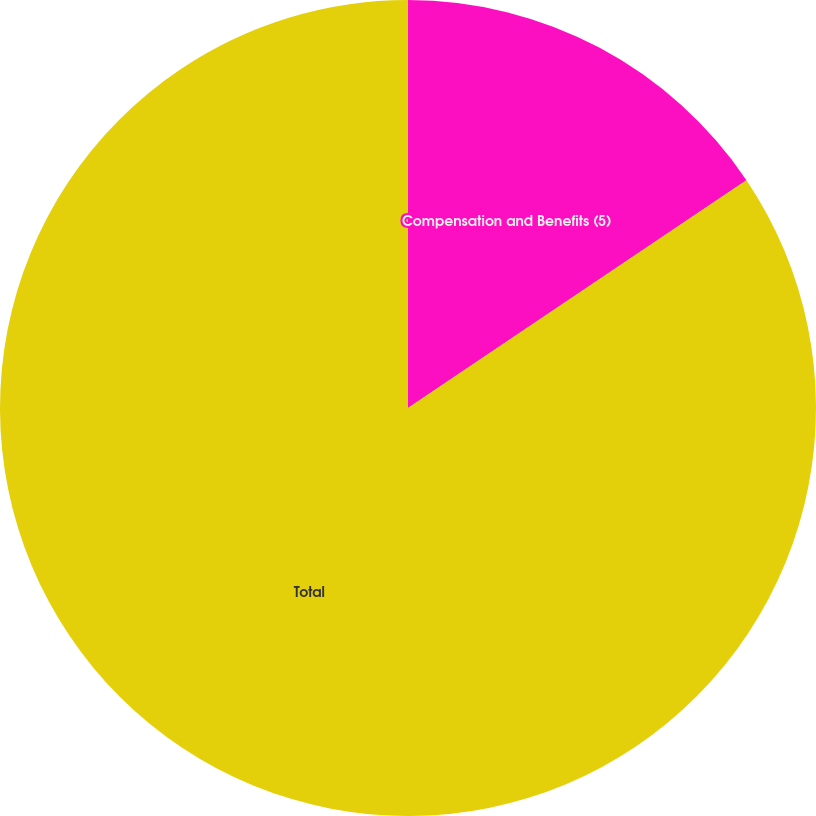<chart> <loc_0><loc_0><loc_500><loc_500><pie_chart><fcel>Compensation and Benefits (5)<fcel>Total<nl><fcel>15.57%<fcel>84.43%<nl></chart> 